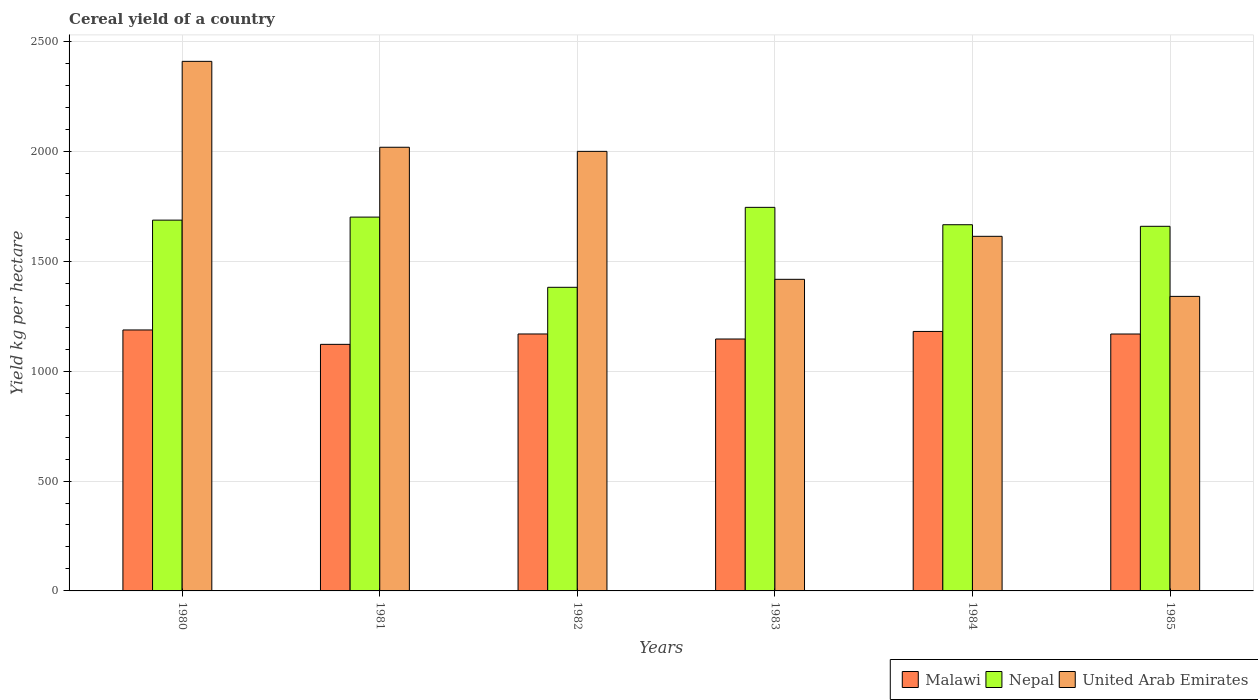Are the number of bars per tick equal to the number of legend labels?
Give a very brief answer. Yes. How many bars are there on the 2nd tick from the left?
Ensure brevity in your answer.  3. How many bars are there on the 2nd tick from the right?
Provide a short and direct response. 3. What is the label of the 3rd group of bars from the left?
Provide a succinct answer. 1982. What is the total cereal yield in Nepal in 1981?
Offer a very short reply. 1700.92. Across all years, what is the maximum total cereal yield in Malawi?
Provide a short and direct response. 1187.38. Across all years, what is the minimum total cereal yield in Malawi?
Provide a succinct answer. 1121.94. In which year was the total cereal yield in United Arab Emirates maximum?
Your answer should be very brief. 1980. In which year was the total cereal yield in Malawi minimum?
Your response must be concise. 1981. What is the total total cereal yield in Nepal in the graph?
Your answer should be very brief. 9840.09. What is the difference between the total cereal yield in Malawi in 1982 and that in 1983?
Keep it short and to the point. 22.91. What is the difference between the total cereal yield in United Arab Emirates in 1982 and the total cereal yield in Malawi in 1985?
Give a very brief answer. 831. What is the average total cereal yield in United Arab Emirates per year?
Your response must be concise. 1799.94. In the year 1984, what is the difference between the total cereal yield in Nepal and total cereal yield in Malawi?
Your answer should be compact. 485.6. What is the ratio of the total cereal yield in Malawi in 1982 to that in 1983?
Offer a very short reply. 1.02. Is the total cereal yield in Malawi in 1981 less than that in 1982?
Make the answer very short. Yes. Is the difference between the total cereal yield in Nepal in 1980 and 1985 greater than the difference between the total cereal yield in Malawi in 1980 and 1985?
Offer a very short reply. Yes. What is the difference between the highest and the second highest total cereal yield in Nepal?
Ensure brevity in your answer.  44.34. What is the difference between the highest and the lowest total cereal yield in Nepal?
Offer a terse response. 363.75. In how many years, is the total cereal yield in United Arab Emirates greater than the average total cereal yield in United Arab Emirates taken over all years?
Give a very brief answer. 3. Is the sum of the total cereal yield in Nepal in 1984 and 1985 greater than the maximum total cereal yield in Malawi across all years?
Make the answer very short. Yes. What does the 1st bar from the left in 1983 represents?
Make the answer very short. Malawi. What does the 1st bar from the right in 1983 represents?
Ensure brevity in your answer.  United Arab Emirates. How many bars are there?
Ensure brevity in your answer.  18. Are all the bars in the graph horizontal?
Provide a short and direct response. No. How many years are there in the graph?
Provide a short and direct response. 6. What is the difference between two consecutive major ticks on the Y-axis?
Make the answer very short. 500. How are the legend labels stacked?
Give a very brief answer. Horizontal. What is the title of the graph?
Provide a succinct answer. Cereal yield of a country. Does "Sierra Leone" appear as one of the legend labels in the graph?
Your answer should be compact. No. What is the label or title of the X-axis?
Your answer should be compact. Years. What is the label or title of the Y-axis?
Provide a short and direct response. Yield kg per hectare. What is the Yield kg per hectare of Malawi in 1980?
Your answer should be compact. 1187.38. What is the Yield kg per hectare in Nepal in 1980?
Make the answer very short. 1687.14. What is the Yield kg per hectare of United Arab Emirates in 1980?
Your answer should be very brief. 2409.57. What is the Yield kg per hectare in Malawi in 1981?
Make the answer very short. 1121.94. What is the Yield kg per hectare in Nepal in 1981?
Your answer should be very brief. 1700.92. What is the Yield kg per hectare of United Arab Emirates in 1981?
Your answer should be very brief. 2018.67. What is the Yield kg per hectare in Malawi in 1982?
Offer a very short reply. 1169.14. What is the Yield kg per hectare in Nepal in 1982?
Offer a terse response. 1381.51. What is the Yield kg per hectare of Malawi in 1983?
Keep it short and to the point. 1146.22. What is the Yield kg per hectare in Nepal in 1983?
Offer a very short reply. 1745.26. What is the Yield kg per hectare of United Arab Emirates in 1983?
Your answer should be compact. 1417.78. What is the Yield kg per hectare in Malawi in 1984?
Keep it short and to the point. 1180.6. What is the Yield kg per hectare in Nepal in 1984?
Keep it short and to the point. 1666.2. What is the Yield kg per hectare in United Arab Emirates in 1984?
Give a very brief answer. 1613.44. What is the Yield kg per hectare of Malawi in 1985?
Make the answer very short. 1169. What is the Yield kg per hectare in Nepal in 1985?
Make the answer very short. 1659.06. What is the Yield kg per hectare of United Arab Emirates in 1985?
Offer a terse response. 1340.21. Across all years, what is the maximum Yield kg per hectare in Malawi?
Make the answer very short. 1187.38. Across all years, what is the maximum Yield kg per hectare of Nepal?
Your answer should be compact. 1745.26. Across all years, what is the maximum Yield kg per hectare of United Arab Emirates?
Provide a short and direct response. 2409.57. Across all years, what is the minimum Yield kg per hectare of Malawi?
Your response must be concise. 1121.94. Across all years, what is the minimum Yield kg per hectare of Nepal?
Your answer should be compact. 1381.51. Across all years, what is the minimum Yield kg per hectare of United Arab Emirates?
Your answer should be compact. 1340.21. What is the total Yield kg per hectare in Malawi in the graph?
Keep it short and to the point. 6974.28. What is the total Yield kg per hectare of Nepal in the graph?
Provide a short and direct response. 9840.09. What is the total Yield kg per hectare of United Arab Emirates in the graph?
Offer a terse response. 1.08e+04. What is the difference between the Yield kg per hectare in Malawi in 1980 and that in 1981?
Your answer should be very brief. 65.44. What is the difference between the Yield kg per hectare in Nepal in 1980 and that in 1981?
Provide a succinct answer. -13.78. What is the difference between the Yield kg per hectare in United Arab Emirates in 1980 and that in 1981?
Offer a very short reply. 390.91. What is the difference between the Yield kg per hectare of Malawi in 1980 and that in 1982?
Your answer should be very brief. 18.24. What is the difference between the Yield kg per hectare of Nepal in 1980 and that in 1982?
Keep it short and to the point. 305.62. What is the difference between the Yield kg per hectare of United Arab Emirates in 1980 and that in 1982?
Your response must be concise. 409.57. What is the difference between the Yield kg per hectare of Malawi in 1980 and that in 1983?
Keep it short and to the point. 41.16. What is the difference between the Yield kg per hectare in Nepal in 1980 and that in 1983?
Make the answer very short. -58.12. What is the difference between the Yield kg per hectare of United Arab Emirates in 1980 and that in 1983?
Your response must be concise. 991.8. What is the difference between the Yield kg per hectare of Malawi in 1980 and that in 1984?
Offer a terse response. 6.78. What is the difference between the Yield kg per hectare in Nepal in 1980 and that in 1984?
Offer a terse response. 20.94. What is the difference between the Yield kg per hectare in United Arab Emirates in 1980 and that in 1984?
Your answer should be very brief. 796.13. What is the difference between the Yield kg per hectare of Malawi in 1980 and that in 1985?
Offer a terse response. 18.38. What is the difference between the Yield kg per hectare in Nepal in 1980 and that in 1985?
Ensure brevity in your answer.  28.08. What is the difference between the Yield kg per hectare in United Arab Emirates in 1980 and that in 1985?
Give a very brief answer. 1069.37. What is the difference between the Yield kg per hectare in Malawi in 1981 and that in 1982?
Make the answer very short. -47.2. What is the difference between the Yield kg per hectare of Nepal in 1981 and that in 1982?
Your response must be concise. 319.41. What is the difference between the Yield kg per hectare in United Arab Emirates in 1981 and that in 1982?
Provide a short and direct response. 18.67. What is the difference between the Yield kg per hectare of Malawi in 1981 and that in 1983?
Offer a terse response. -24.28. What is the difference between the Yield kg per hectare in Nepal in 1981 and that in 1983?
Your response must be concise. -44.34. What is the difference between the Yield kg per hectare of United Arab Emirates in 1981 and that in 1983?
Your answer should be compact. 600.89. What is the difference between the Yield kg per hectare in Malawi in 1981 and that in 1984?
Keep it short and to the point. -58.66. What is the difference between the Yield kg per hectare in Nepal in 1981 and that in 1984?
Ensure brevity in your answer.  34.72. What is the difference between the Yield kg per hectare in United Arab Emirates in 1981 and that in 1984?
Your answer should be very brief. 405.22. What is the difference between the Yield kg per hectare in Malawi in 1981 and that in 1985?
Offer a very short reply. -47.06. What is the difference between the Yield kg per hectare in Nepal in 1981 and that in 1985?
Your answer should be very brief. 41.86. What is the difference between the Yield kg per hectare in United Arab Emirates in 1981 and that in 1985?
Offer a terse response. 678.46. What is the difference between the Yield kg per hectare of Malawi in 1982 and that in 1983?
Provide a succinct answer. 22.91. What is the difference between the Yield kg per hectare of Nepal in 1982 and that in 1983?
Ensure brevity in your answer.  -363.75. What is the difference between the Yield kg per hectare in United Arab Emirates in 1982 and that in 1983?
Your answer should be compact. 582.22. What is the difference between the Yield kg per hectare in Malawi in 1982 and that in 1984?
Give a very brief answer. -11.46. What is the difference between the Yield kg per hectare of Nepal in 1982 and that in 1984?
Provide a succinct answer. -284.69. What is the difference between the Yield kg per hectare of United Arab Emirates in 1982 and that in 1984?
Keep it short and to the point. 386.56. What is the difference between the Yield kg per hectare of Malawi in 1982 and that in 1985?
Give a very brief answer. 0.14. What is the difference between the Yield kg per hectare of Nepal in 1982 and that in 1985?
Offer a terse response. -277.54. What is the difference between the Yield kg per hectare of United Arab Emirates in 1982 and that in 1985?
Your answer should be compact. 659.79. What is the difference between the Yield kg per hectare of Malawi in 1983 and that in 1984?
Your answer should be very brief. -34.38. What is the difference between the Yield kg per hectare in Nepal in 1983 and that in 1984?
Provide a short and direct response. 79.06. What is the difference between the Yield kg per hectare in United Arab Emirates in 1983 and that in 1984?
Provide a short and direct response. -195.67. What is the difference between the Yield kg per hectare in Malawi in 1983 and that in 1985?
Your answer should be very brief. -22.78. What is the difference between the Yield kg per hectare in Nepal in 1983 and that in 1985?
Make the answer very short. 86.2. What is the difference between the Yield kg per hectare in United Arab Emirates in 1983 and that in 1985?
Your answer should be very brief. 77.57. What is the difference between the Yield kg per hectare of Nepal in 1984 and that in 1985?
Give a very brief answer. 7.14. What is the difference between the Yield kg per hectare in United Arab Emirates in 1984 and that in 1985?
Make the answer very short. 273.24. What is the difference between the Yield kg per hectare of Malawi in 1980 and the Yield kg per hectare of Nepal in 1981?
Offer a terse response. -513.54. What is the difference between the Yield kg per hectare of Malawi in 1980 and the Yield kg per hectare of United Arab Emirates in 1981?
Make the answer very short. -831.29. What is the difference between the Yield kg per hectare of Nepal in 1980 and the Yield kg per hectare of United Arab Emirates in 1981?
Offer a very short reply. -331.53. What is the difference between the Yield kg per hectare of Malawi in 1980 and the Yield kg per hectare of Nepal in 1982?
Keep it short and to the point. -194.13. What is the difference between the Yield kg per hectare in Malawi in 1980 and the Yield kg per hectare in United Arab Emirates in 1982?
Your answer should be compact. -812.62. What is the difference between the Yield kg per hectare in Nepal in 1980 and the Yield kg per hectare in United Arab Emirates in 1982?
Your answer should be compact. -312.86. What is the difference between the Yield kg per hectare of Malawi in 1980 and the Yield kg per hectare of Nepal in 1983?
Offer a very short reply. -557.88. What is the difference between the Yield kg per hectare of Malawi in 1980 and the Yield kg per hectare of United Arab Emirates in 1983?
Your answer should be very brief. -230.4. What is the difference between the Yield kg per hectare of Nepal in 1980 and the Yield kg per hectare of United Arab Emirates in 1983?
Make the answer very short. 269.36. What is the difference between the Yield kg per hectare of Malawi in 1980 and the Yield kg per hectare of Nepal in 1984?
Your answer should be very brief. -478.82. What is the difference between the Yield kg per hectare of Malawi in 1980 and the Yield kg per hectare of United Arab Emirates in 1984?
Provide a succinct answer. -426.06. What is the difference between the Yield kg per hectare in Nepal in 1980 and the Yield kg per hectare in United Arab Emirates in 1984?
Your answer should be very brief. 73.69. What is the difference between the Yield kg per hectare of Malawi in 1980 and the Yield kg per hectare of Nepal in 1985?
Provide a succinct answer. -471.68. What is the difference between the Yield kg per hectare of Malawi in 1980 and the Yield kg per hectare of United Arab Emirates in 1985?
Keep it short and to the point. -152.82. What is the difference between the Yield kg per hectare in Nepal in 1980 and the Yield kg per hectare in United Arab Emirates in 1985?
Your response must be concise. 346.93. What is the difference between the Yield kg per hectare in Malawi in 1981 and the Yield kg per hectare in Nepal in 1982?
Offer a very short reply. -259.57. What is the difference between the Yield kg per hectare of Malawi in 1981 and the Yield kg per hectare of United Arab Emirates in 1982?
Offer a terse response. -878.06. What is the difference between the Yield kg per hectare of Nepal in 1981 and the Yield kg per hectare of United Arab Emirates in 1982?
Offer a terse response. -299.08. What is the difference between the Yield kg per hectare of Malawi in 1981 and the Yield kg per hectare of Nepal in 1983?
Offer a very short reply. -623.32. What is the difference between the Yield kg per hectare of Malawi in 1981 and the Yield kg per hectare of United Arab Emirates in 1983?
Provide a succinct answer. -295.84. What is the difference between the Yield kg per hectare in Nepal in 1981 and the Yield kg per hectare in United Arab Emirates in 1983?
Offer a terse response. 283.14. What is the difference between the Yield kg per hectare of Malawi in 1981 and the Yield kg per hectare of Nepal in 1984?
Provide a succinct answer. -544.26. What is the difference between the Yield kg per hectare in Malawi in 1981 and the Yield kg per hectare in United Arab Emirates in 1984?
Provide a short and direct response. -491.5. What is the difference between the Yield kg per hectare in Nepal in 1981 and the Yield kg per hectare in United Arab Emirates in 1984?
Offer a terse response. 87.47. What is the difference between the Yield kg per hectare of Malawi in 1981 and the Yield kg per hectare of Nepal in 1985?
Your response must be concise. -537.12. What is the difference between the Yield kg per hectare of Malawi in 1981 and the Yield kg per hectare of United Arab Emirates in 1985?
Keep it short and to the point. -218.27. What is the difference between the Yield kg per hectare in Nepal in 1981 and the Yield kg per hectare in United Arab Emirates in 1985?
Your response must be concise. 360.71. What is the difference between the Yield kg per hectare of Malawi in 1982 and the Yield kg per hectare of Nepal in 1983?
Provide a succinct answer. -576.12. What is the difference between the Yield kg per hectare in Malawi in 1982 and the Yield kg per hectare in United Arab Emirates in 1983?
Make the answer very short. -248.64. What is the difference between the Yield kg per hectare of Nepal in 1982 and the Yield kg per hectare of United Arab Emirates in 1983?
Offer a terse response. -36.26. What is the difference between the Yield kg per hectare of Malawi in 1982 and the Yield kg per hectare of Nepal in 1984?
Offer a very short reply. -497.06. What is the difference between the Yield kg per hectare in Malawi in 1982 and the Yield kg per hectare in United Arab Emirates in 1984?
Ensure brevity in your answer.  -444.31. What is the difference between the Yield kg per hectare in Nepal in 1982 and the Yield kg per hectare in United Arab Emirates in 1984?
Your response must be concise. -231.93. What is the difference between the Yield kg per hectare of Malawi in 1982 and the Yield kg per hectare of Nepal in 1985?
Your answer should be compact. -489.92. What is the difference between the Yield kg per hectare in Malawi in 1982 and the Yield kg per hectare in United Arab Emirates in 1985?
Make the answer very short. -171.07. What is the difference between the Yield kg per hectare of Nepal in 1982 and the Yield kg per hectare of United Arab Emirates in 1985?
Provide a succinct answer. 41.31. What is the difference between the Yield kg per hectare of Malawi in 1983 and the Yield kg per hectare of Nepal in 1984?
Your answer should be very brief. -519.98. What is the difference between the Yield kg per hectare of Malawi in 1983 and the Yield kg per hectare of United Arab Emirates in 1984?
Give a very brief answer. -467.22. What is the difference between the Yield kg per hectare of Nepal in 1983 and the Yield kg per hectare of United Arab Emirates in 1984?
Provide a succinct answer. 131.81. What is the difference between the Yield kg per hectare in Malawi in 1983 and the Yield kg per hectare in Nepal in 1985?
Make the answer very short. -512.84. What is the difference between the Yield kg per hectare in Malawi in 1983 and the Yield kg per hectare in United Arab Emirates in 1985?
Your answer should be compact. -193.98. What is the difference between the Yield kg per hectare in Nepal in 1983 and the Yield kg per hectare in United Arab Emirates in 1985?
Your answer should be very brief. 405.05. What is the difference between the Yield kg per hectare in Malawi in 1984 and the Yield kg per hectare in Nepal in 1985?
Provide a succinct answer. -478.46. What is the difference between the Yield kg per hectare of Malawi in 1984 and the Yield kg per hectare of United Arab Emirates in 1985?
Offer a very short reply. -159.61. What is the difference between the Yield kg per hectare in Nepal in 1984 and the Yield kg per hectare in United Arab Emirates in 1985?
Make the answer very short. 326. What is the average Yield kg per hectare in Malawi per year?
Provide a short and direct response. 1162.38. What is the average Yield kg per hectare of Nepal per year?
Offer a terse response. 1640.01. What is the average Yield kg per hectare of United Arab Emirates per year?
Provide a short and direct response. 1799.94. In the year 1980, what is the difference between the Yield kg per hectare in Malawi and Yield kg per hectare in Nepal?
Provide a succinct answer. -499.76. In the year 1980, what is the difference between the Yield kg per hectare in Malawi and Yield kg per hectare in United Arab Emirates?
Provide a short and direct response. -1222.19. In the year 1980, what is the difference between the Yield kg per hectare of Nepal and Yield kg per hectare of United Arab Emirates?
Your answer should be compact. -722.44. In the year 1981, what is the difference between the Yield kg per hectare in Malawi and Yield kg per hectare in Nepal?
Provide a short and direct response. -578.98. In the year 1981, what is the difference between the Yield kg per hectare in Malawi and Yield kg per hectare in United Arab Emirates?
Provide a succinct answer. -896.73. In the year 1981, what is the difference between the Yield kg per hectare in Nepal and Yield kg per hectare in United Arab Emirates?
Give a very brief answer. -317.75. In the year 1982, what is the difference between the Yield kg per hectare in Malawi and Yield kg per hectare in Nepal?
Your answer should be very brief. -212.38. In the year 1982, what is the difference between the Yield kg per hectare of Malawi and Yield kg per hectare of United Arab Emirates?
Provide a succinct answer. -830.86. In the year 1982, what is the difference between the Yield kg per hectare of Nepal and Yield kg per hectare of United Arab Emirates?
Your answer should be compact. -618.49. In the year 1983, what is the difference between the Yield kg per hectare of Malawi and Yield kg per hectare of Nepal?
Make the answer very short. -599.04. In the year 1983, what is the difference between the Yield kg per hectare of Malawi and Yield kg per hectare of United Arab Emirates?
Keep it short and to the point. -271.56. In the year 1983, what is the difference between the Yield kg per hectare of Nepal and Yield kg per hectare of United Arab Emirates?
Keep it short and to the point. 327.48. In the year 1984, what is the difference between the Yield kg per hectare of Malawi and Yield kg per hectare of Nepal?
Make the answer very short. -485.6. In the year 1984, what is the difference between the Yield kg per hectare in Malawi and Yield kg per hectare in United Arab Emirates?
Give a very brief answer. -432.85. In the year 1984, what is the difference between the Yield kg per hectare in Nepal and Yield kg per hectare in United Arab Emirates?
Provide a short and direct response. 52.76. In the year 1985, what is the difference between the Yield kg per hectare of Malawi and Yield kg per hectare of Nepal?
Offer a terse response. -490.06. In the year 1985, what is the difference between the Yield kg per hectare in Malawi and Yield kg per hectare in United Arab Emirates?
Keep it short and to the point. -171.21. In the year 1985, what is the difference between the Yield kg per hectare of Nepal and Yield kg per hectare of United Arab Emirates?
Keep it short and to the point. 318.85. What is the ratio of the Yield kg per hectare of Malawi in 1980 to that in 1981?
Provide a short and direct response. 1.06. What is the ratio of the Yield kg per hectare of Nepal in 1980 to that in 1981?
Ensure brevity in your answer.  0.99. What is the ratio of the Yield kg per hectare of United Arab Emirates in 1980 to that in 1981?
Provide a succinct answer. 1.19. What is the ratio of the Yield kg per hectare in Malawi in 1980 to that in 1982?
Provide a succinct answer. 1.02. What is the ratio of the Yield kg per hectare of Nepal in 1980 to that in 1982?
Your answer should be compact. 1.22. What is the ratio of the Yield kg per hectare of United Arab Emirates in 1980 to that in 1982?
Give a very brief answer. 1.2. What is the ratio of the Yield kg per hectare in Malawi in 1980 to that in 1983?
Keep it short and to the point. 1.04. What is the ratio of the Yield kg per hectare in Nepal in 1980 to that in 1983?
Make the answer very short. 0.97. What is the ratio of the Yield kg per hectare of United Arab Emirates in 1980 to that in 1983?
Provide a succinct answer. 1.7. What is the ratio of the Yield kg per hectare of Malawi in 1980 to that in 1984?
Give a very brief answer. 1.01. What is the ratio of the Yield kg per hectare in Nepal in 1980 to that in 1984?
Offer a very short reply. 1.01. What is the ratio of the Yield kg per hectare in United Arab Emirates in 1980 to that in 1984?
Make the answer very short. 1.49. What is the ratio of the Yield kg per hectare of Malawi in 1980 to that in 1985?
Your answer should be compact. 1.02. What is the ratio of the Yield kg per hectare of Nepal in 1980 to that in 1985?
Your response must be concise. 1.02. What is the ratio of the Yield kg per hectare of United Arab Emirates in 1980 to that in 1985?
Your answer should be very brief. 1.8. What is the ratio of the Yield kg per hectare in Malawi in 1981 to that in 1982?
Provide a succinct answer. 0.96. What is the ratio of the Yield kg per hectare in Nepal in 1981 to that in 1982?
Your answer should be very brief. 1.23. What is the ratio of the Yield kg per hectare of United Arab Emirates in 1981 to that in 1982?
Give a very brief answer. 1.01. What is the ratio of the Yield kg per hectare in Malawi in 1981 to that in 1983?
Provide a short and direct response. 0.98. What is the ratio of the Yield kg per hectare of Nepal in 1981 to that in 1983?
Provide a short and direct response. 0.97. What is the ratio of the Yield kg per hectare of United Arab Emirates in 1981 to that in 1983?
Make the answer very short. 1.42. What is the ratio of the Yield kg per hectare in Malawi in 1981 to that in 1984?
Provide a short and direct response. 0.95. What is the ratio of the Yield kg per hectare of Nepal in 1981 to that in 1984?
Offer a very short reply. 1.02. What is the ratio of the Yield kg per hectare of United Arab Emirates in 1981 to that in 1984?
Make the answer very short. 1.25. What is the ratio of the Yield kg per hectare of Malawi in 1981 to that in 1985?
Offer a very short reply. 0.96. What is the ratio of the Yield kg per hectare of Nepal in 1981 to that in 1985?
Ensure brevity in your answer.  1.03. What is the ratio of the Yield kg per hectare in United Arab Emirates in 1981 to that in 1985?
Offer a very short reply. 1.51. What is the ratio of the Yield kg per hectare of Nepal in 1982 to that in 1983?
Your answer should be compact. 0.79. What is the ratio of the Yield kg per hectare in United Arab Emirates in 1982 to that in 1983?
Ensure brevity in your answer.  1.41. What is the ratio of the Yield kg per hectare of Malawi in 1982 to that in 1984?
Your answer should be compact. 0.99. What is the ratio of the Yield kg per hectare in Nepal in 1982 to that in 1984?
Ensure brevity in your answer.  0.83. What is the ratio of the Yield kg per hectare in United Arab Emirates in 1982 to that in 1984?
Your response must be concise. 1.24. What is the ratio of the Yield kg per hectare of Malawi in 1982 to that in 1985?
Make the answer very short. 1. What is the ratio of the Yield kg per hectare of Nepal in 1982 to that in 1985?
Your response must be concise. 0.83. What is the ratio of the Yield kg per hectare in United Arab Emirates in 1982 to that in 1985?
Your response must be concise. 1.49. What is the ratio of the Yield kg per hectare of Malawi in 1983 to that in 1984?
Offer a very short reply. 0.97. What is the ratio of the Yield kg per hectare in Nepal in 1983 to that in 1984?
Offer a terse response. 1.05. What is the ratio of the Yield kg per hectare in United Arab Emirates in 1983 to that in 1984?
Provide a short and direct response. 0.88. What is the ratio of the Yield kg per hectare in Malawi in 1983 to that in 1985?
Your response must be concise. 0.98. What is the ratio of the Yield kg per hectare of Nepal in 1983 to that in 1985?
Ensure brevity in your answer.  1.05. What is the ratio of the Yield kg per hectare in United Arab Emirates in 1983 to that in 1985?
Offer a terse response. 1.06. What is the ratio of the Yield kg per hectare in Malawi in 1984 to that in 1985?
Keep it short and to the point. 1.01. What is the ratio of the Yield kg per hectare in Nepal in 1984 to that in 1985?
Your answer should be compact. 1. What is the ratio of the Yield kg per hectare of United Arab Emirates in 1984 to that in 1985?
Ensure brevity in your answer.  1.2. What is the difference between the highest and the second highest Yield kg per hectare in Malawi?
Offer a very short reply. 6.78. What is the difference between the highest and the second highest Yield kg per hectare in Nepal?
Provide a short and direct response. 44.34. What is the difference between the highest and the second highest Yield kg per hectare of United Arab Emirates?
Provide a short and direct response. 390.91. What is the difference between the highest and the lowest Yield kg per hectare of Malawi?
Provide a short and direct response. 65.44. What is the difference between the highest and the lowest Yield kg per hectare in Nepal?
Your answer should be very brief. 363.75. What is the difference between the highest and the lowest Yield kg per hectare in United Arab Emirates?
Your response must be concise. 1069.37. 